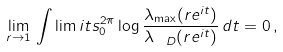Convert formula to latex. <formula><loc_0><loc_0><loc_500><loc_500>\lim _ { r \to 1 } \, \int \lim i t s _ { 0 } ^ { 2 \pi } \log \frac { \lambda _ { \max } ( r e ^ { i t } ) } { \lambda _ { \ D } ( r e ^ { i t } ) } \, d t = 0 \, ,</formula> 